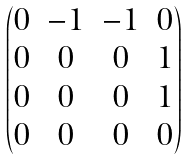<formula> <loc_0><loc_0><loc_500><loc_500>\begin{pmatrix} 0 & - 1 & - 1 & 0 \\ 0 & 0 & 0 & 1 \\ 0 & 0 & 0 & 1 \\ 0 & 0 & 0 & 0 \\ \end{pmatrix}</formula> 